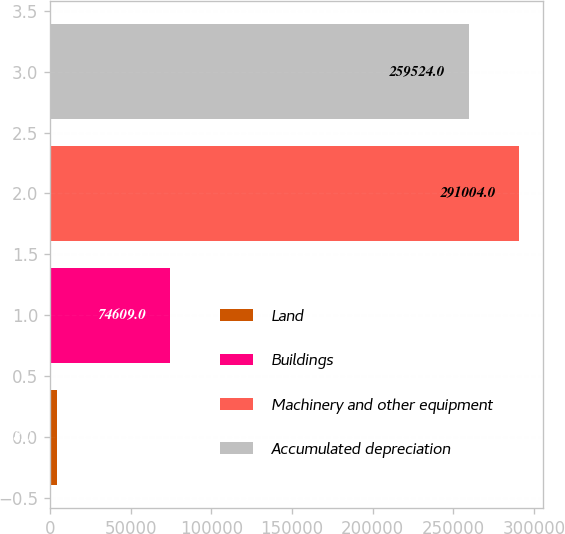Convert chart to OTSL. <chart><loc_0><loc_0><loc_500><loc_500><bar_chart><fcel>Land<fcel>Buildings<fcel>Machinery and other equipment<fcel>Accumulated depreciation<nl><fcel>4308<fcel>74609<fcel>291004<fcel>259524<nl></chart> 